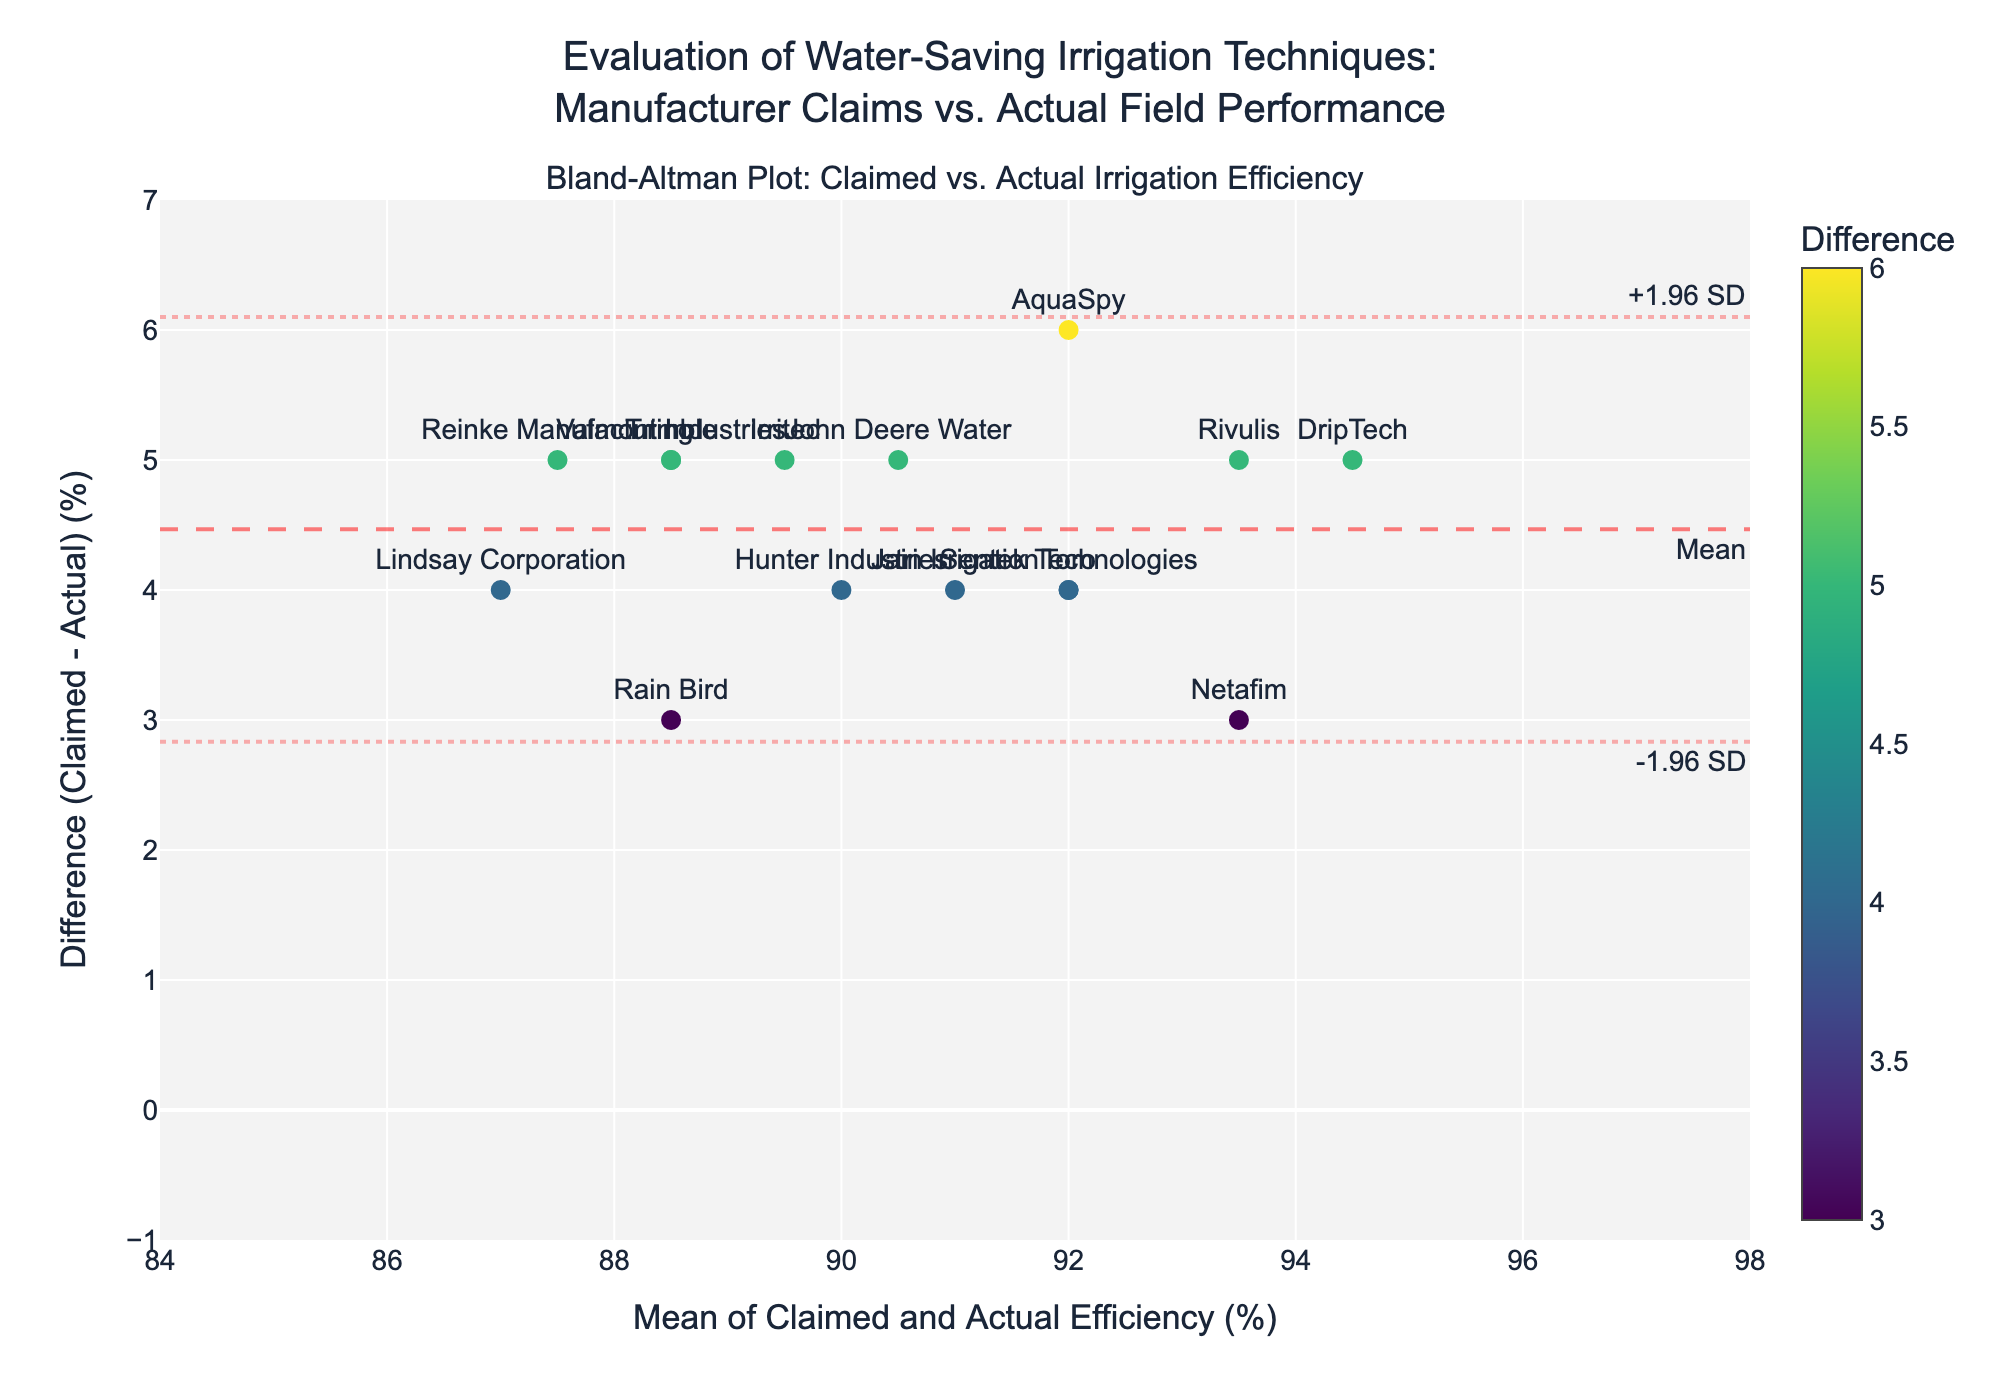What's the title of the plot? To find the title, look at the top-most text in the figure. It typically summarizes the plot's main theme.
Answer: Evaluation of Water-Saving Irrigation Techniques: Manufacturer Claims vs. Actual Field Performance What does the x-axis represent? The x-axis representation is found along the horizontal line at the bottom of the plot. It usually has a title or label describing what values are being measured.
Answer: Mean of Claimed and Actual Efficiency (%) What does the y-axis represent? The y-axis representation is found along the vertical line to the left of the plot. It usually has a title or label describing what values are being measured.
Answer: Difference (Claimed - Actual) (%) How many data points are representing manufacturers? To determine the number of data points, count the number of markers along the scatter plot. Each marker represents one manufacturer.
Answer: 15 Which manufacturers have the highest claimed efficiency? Look for the data point with the highest value on the x-axis and note the associated manufacturer.
Answer: DripTech and Rivulis What is the mean difference (Claimed - Actual) efficiency, and how is it visually represented on the plot? The mean difference is calculated as the average of all differences between claimed and actual efficiencies. It is visually represented by a horizontal dashed line across the plot and often includes text labeling.
Answer: Visually represented by a horizontal dashed line at approximately 4 Are there any manufacturers whose actual efficiency matches the claimed efficiency? Check each data point on the y-axis. If any data point has a y-value of 0, it means claimed efficiency matches the actual efficiency.
Answer: No Which manufacturer has the largest discrepancy between claimed and actual efficiency, and what is the discrepancy? Identify the data point with the highest y-value on the plot, then calculate the difference between its claimed and actual efficiency to determine the discrepancy.
Answer: AquaSpy; Discrepancy is 6% (95 - 89) What are the limits of agreement, and how are they represented visually? The limits of agreement are statistically calculated as mean difference ± 1.96 standard deviations. These are visually represented as dotted lines on the plot, typically with annotation text.
Answer: Approximately 1.78 and 6.22 What is the average of the claimed efficiency and actual efficiency for Toro? To find this value, refer to the data point labeled "Toro" and use the x-axis value, which represents the mean of the claimed and actual efficiency.
Answer: 92 (since (94 + 90)/2 = 92) 